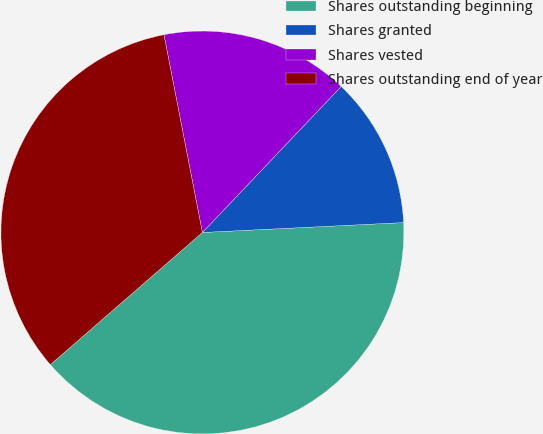Convert chart to OTSL. <chart><loc_0><loc_0><loc_500><loc_500><pie_chart><fcel>Shares outstanding beginning<fcel>Shares granted<fcel>Shares vested<fcel>Shares outstanding end of year<nl><fcel>39.39%<fcel>12.12%<fcel>15.15%<fcel>33.33%<nl></chart> 